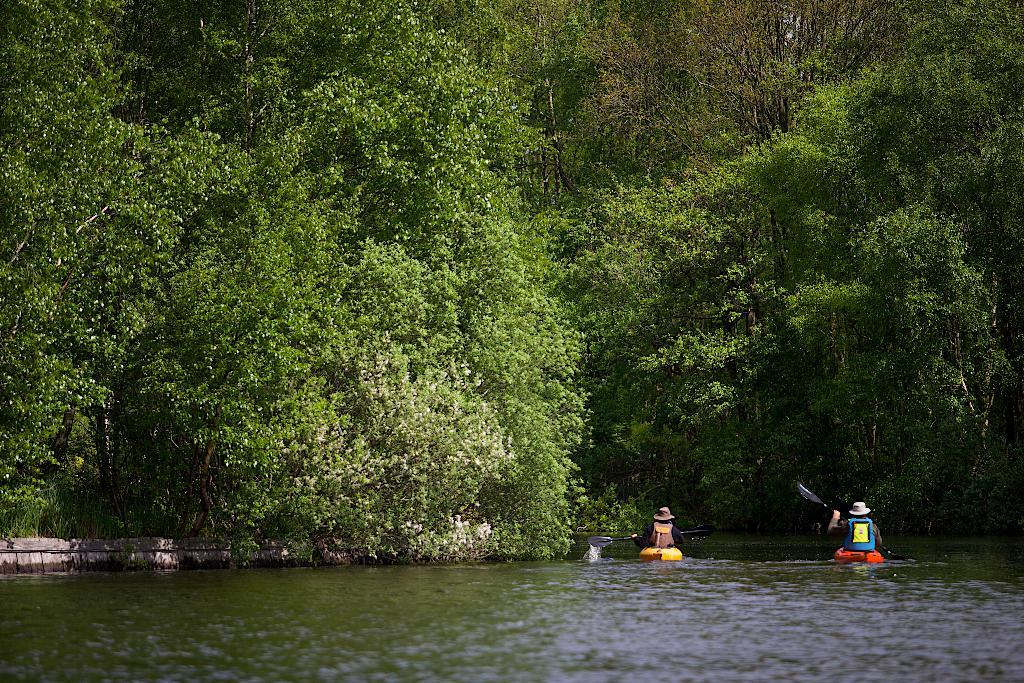What is visible at the bottom of the image? There is water visible at the bottom of the image. How many people are in the image? There are two persons in the image. What are the persons holding in their hands? The persons are holding paddles in their hands. What are the persons sitting on? The persons are sitting on boats. What can be seen in the background of the image? There are many trees in the background of the image. What type of destruction can be seen in the image? There is no destruction present in the image; it features two persons in boats on water with trees in the background. 